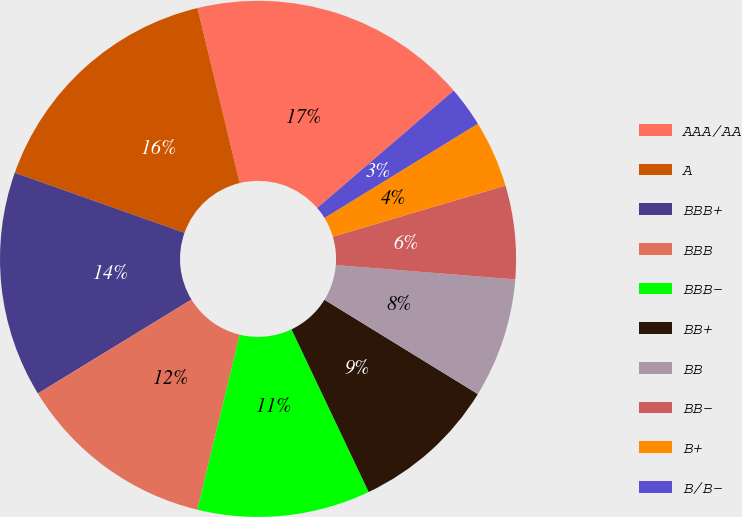Convert chart to OTSL. <chart><loc_0><loc_0><loc_500><loc_500><pie_chart><fcel>AAA/AA<fcel>A<fcel>BBB+<fcel>BBB<fcel>BBB-<fcel>BB+<fcel>BB<fcel>BB-<fcel>B+<fcel>B/B-<nl><fcel>17.47%<fcel>15.81%<fcel>14.15%<fcel>12.49%<fcel>10.83%<fcel>9.17%<fcel>7.51%<fcel>5.85%<fcel>4.19%<fcel>2.53%<nl></chart> 